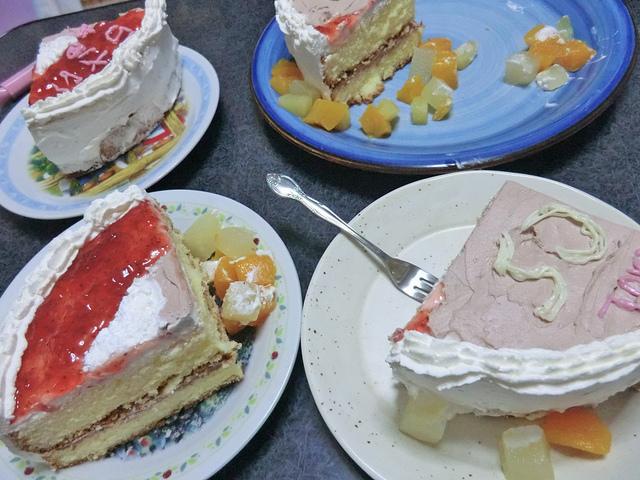How many plates have a fork?
Concise answer only. 1. Are these pieces of cake all from the same cake?
Quick response, please. Yes. What flavor is the cake slice on the left?
Keep it brief. Vanilla. 